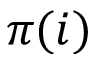<formula> <loc_0><loc_0><loc_500><loc_500>\pi ( i )</formula> 